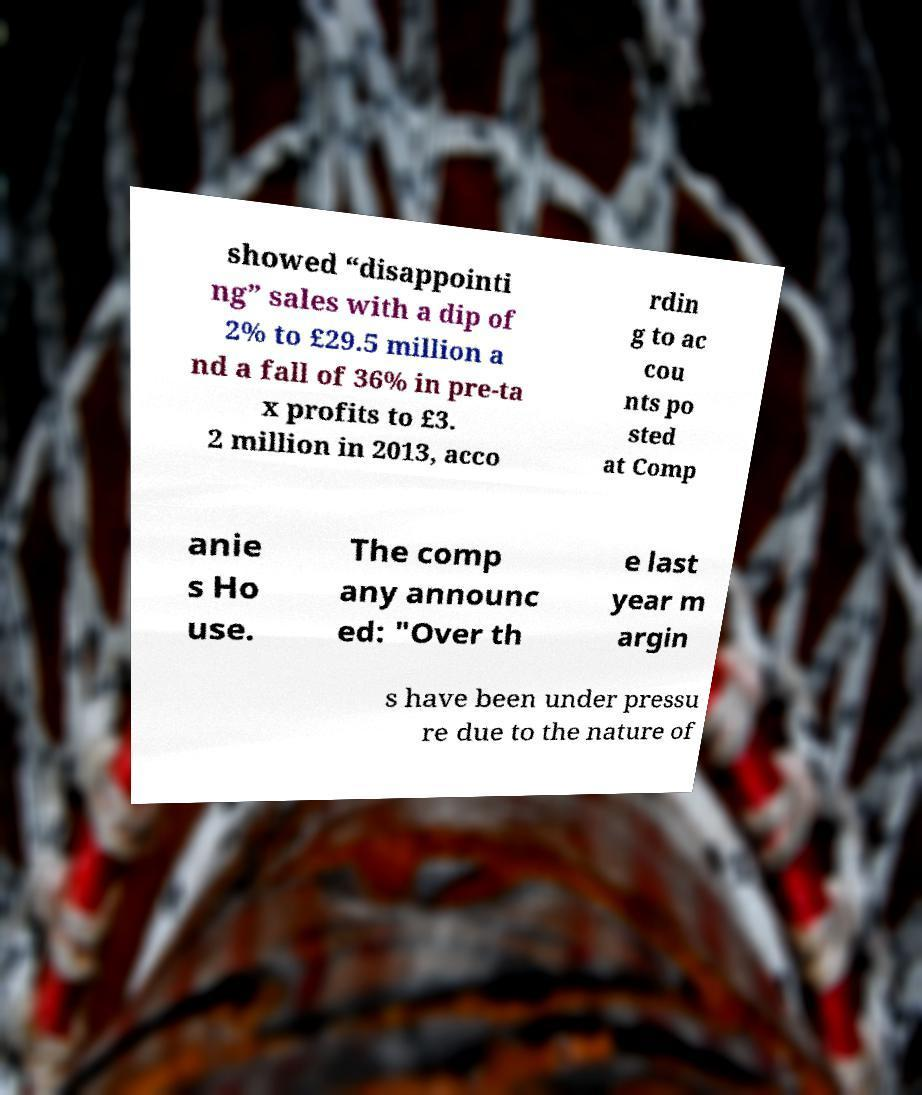For documentation purposes, I need the text within this image transcribed. Could you provide that? showed “disappointi ng” sales with a dip of 2% to £29.5 million a nd a fall of 36% in pre-ta x profits to £3. 2 million in 2013, acco rdin g to ac cou nts po sted at Comp anie s Ho use. The comp any announc ed: "Over th e last year m argin s have been under pressu re due to the nature of 